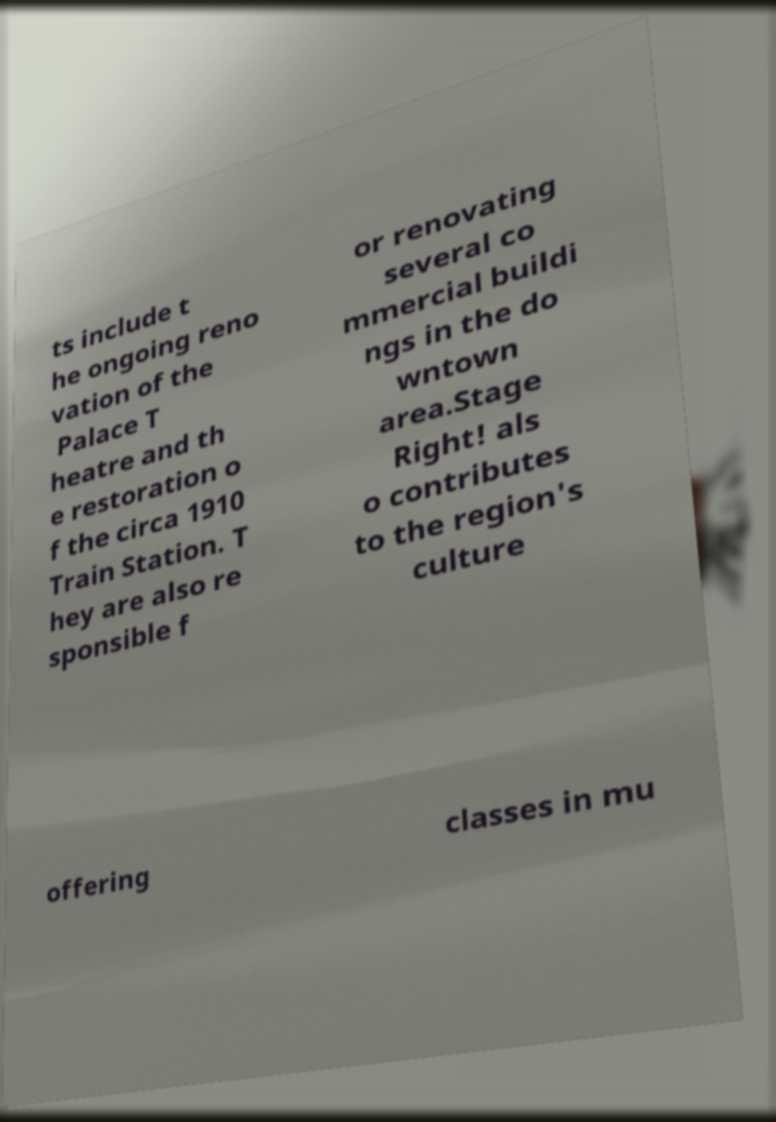Please identify and transcribe the text found in this image. ts include t he ongoing reno vation of the Palace T heatre and th e restoration o f the circa 1910 Train Station. T hey are also re sponsible f or renovating several co mmercial buildi ngs in the do wntown area.Stage Right! als o contributes to the region's culture offering classes in mu 